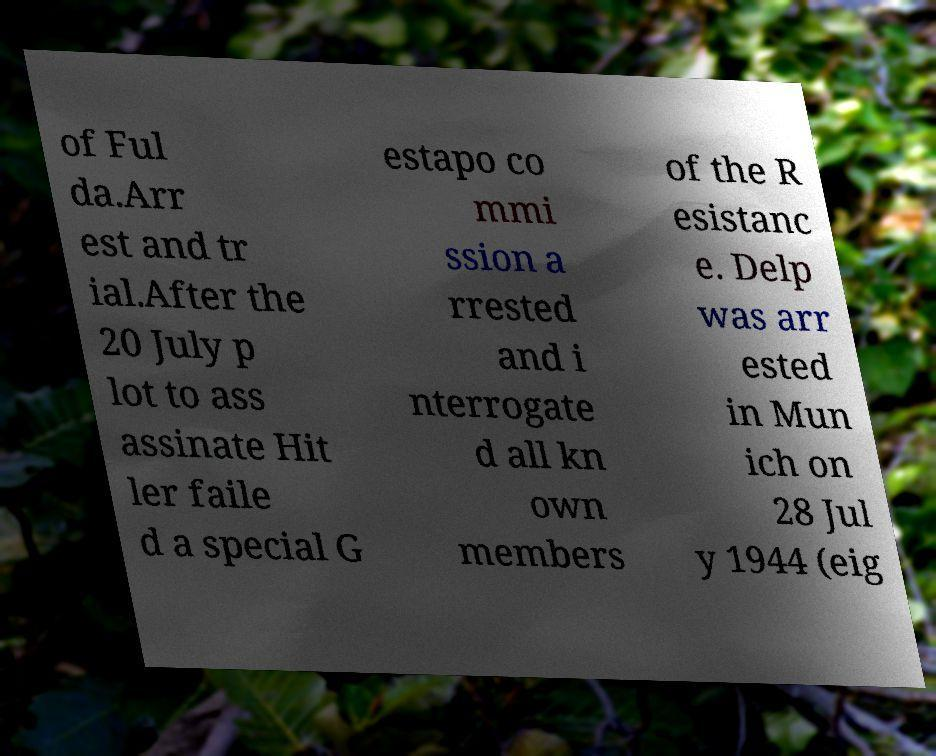Can you read and provide the text displayed in the image?This photo seems to have some interesting text. Can you extract and type it out for me? of Ful da.Arr est and tr ial.After the 20 July p lot to ass assinate Hit ler faile d a special G estapo co mmi ssion a rrested and i nterrogate d all kn own members of the R esistanc e. Delp was arr ested in Mun ich on 28 Jul y 1944 (eig 